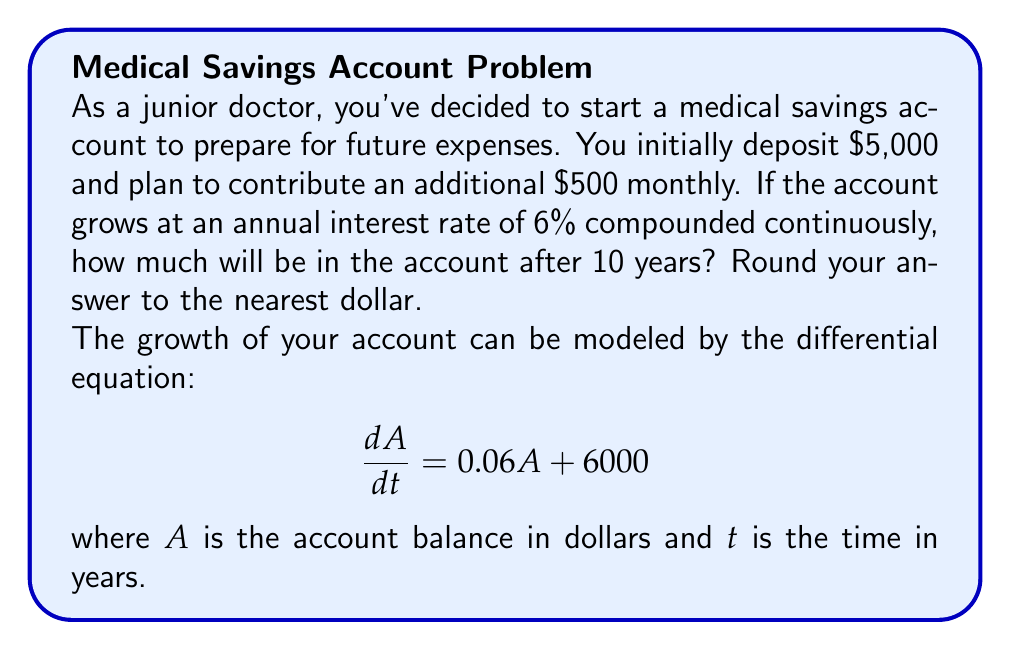What is the answer to this math problem? To solve this problem, we'll use the method for solving non-homogeneous second-order linear differential equations:

1) The general solution to this equation is of the form:
   $$A(t) = c_1e^{0.06t} + c_2$$

2) Substitute this into the original equation:
   $$0.06(c_1e^{0.06t} + c_2) + 6000 = 0.06c_1e^{0.06t} + 0.06c_2 + 6000$$

3) For this to be true for all t, we must have:
   $$0.06c_2 + 6000 = 0$$
   $$c_2 = -100,000$$

4) So our general solution is:
   $$A(t) = c_1e^{0.06t} - 100,000$$

5) To find $c_1$, use the initial condition $A(0) = 5000$:
   $$5000 = c_1 - 100,000$$
   $$c_1 = 105,000$$

6) Our particular solution is:
   $$A(t) = 105,000e^{0.06t} - 100,000$$

7) Evaluate this at t = 10:
   $$A(10) = 105,000e^{0.6} - 100,000$$
   $$= 105,000 * 1.8221188 - 100,000$$
   $$= 191,322.47 - 100,000$$
   $$= 91,322.47$$

8) Rounding to the nearest dollar:
   $$A(10) ≈ $91,322$$
Answer: $91,322 